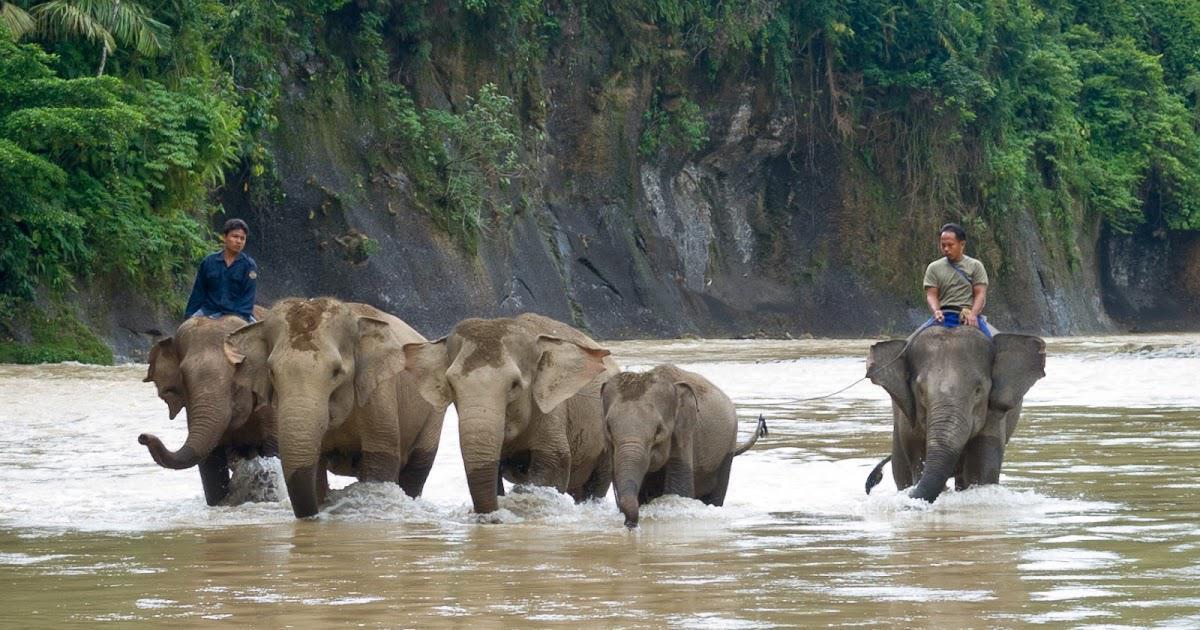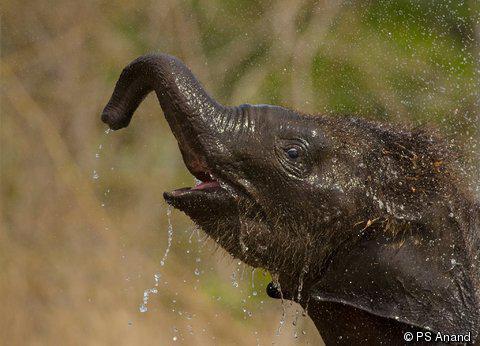The first image is the image on the left, the second image is the image on the right. Considering the images on both sides, is "There is one animal in the image on the right." valid? Answer yes or no. Yes. 